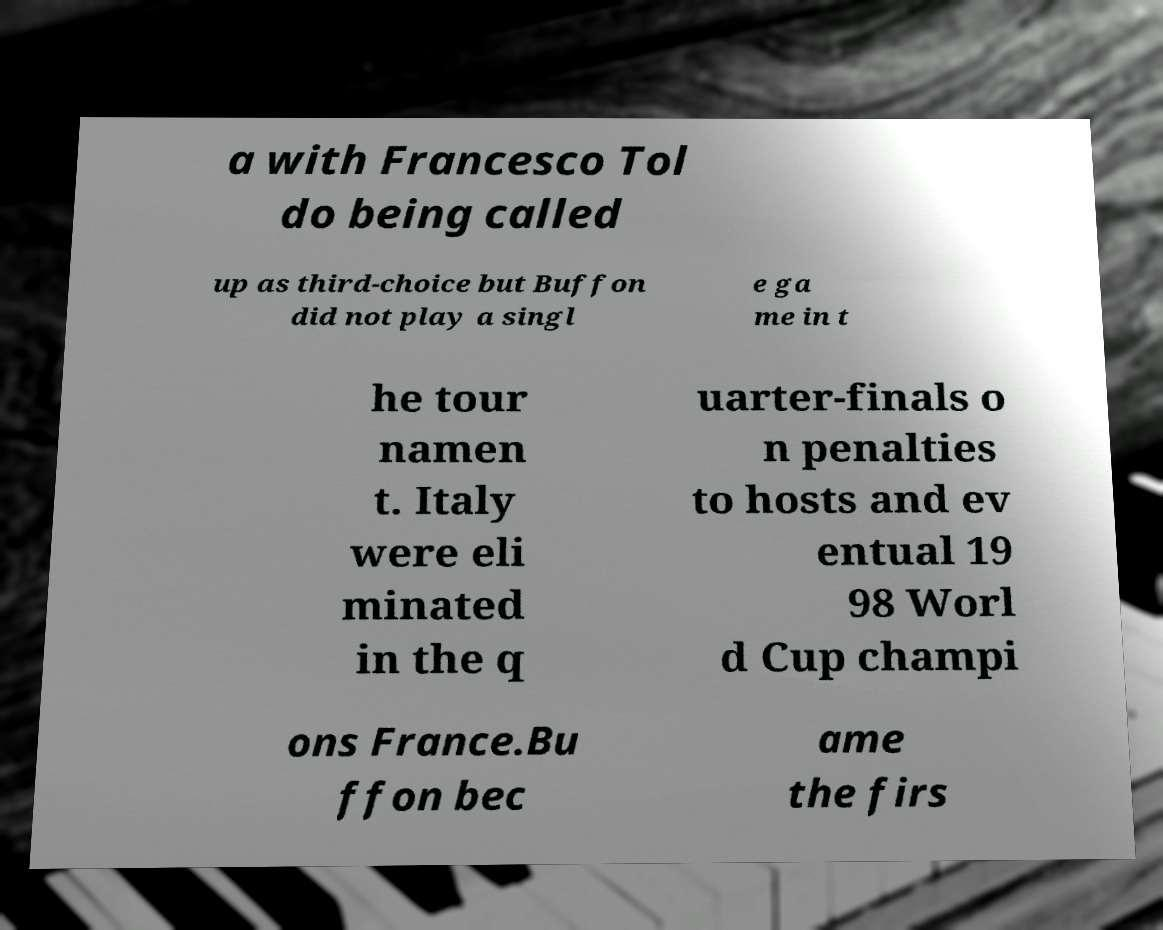Please read and relay the text visible in this image. What does it say? a with Francesco Tol do being called up as third-choice but Buffon did not play a singl e ga me in t he tour namen t. Italy were eli minated in the q uarter-finals o n penalties to hosts and ev entual 19 98 Worl d Cup champi ons France.Bu ffon bec ame the firs 